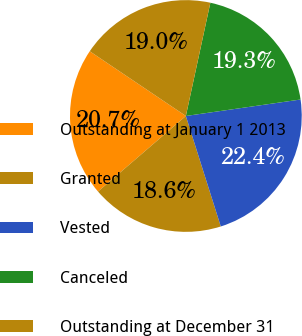<chart> <loc_0><loc_0><loc_500><loc_500><pie_chart><fcel>Outstanding at January 1 2013<fcel>Granted<fcel>Vested<fcel>Canceled<fcel>Outstanding at December 31<nl><fcel>20.74%<fcel>18.57%<fcel>22.4%<fcel>19.34%<fcel>18.96%<nl></chart> 